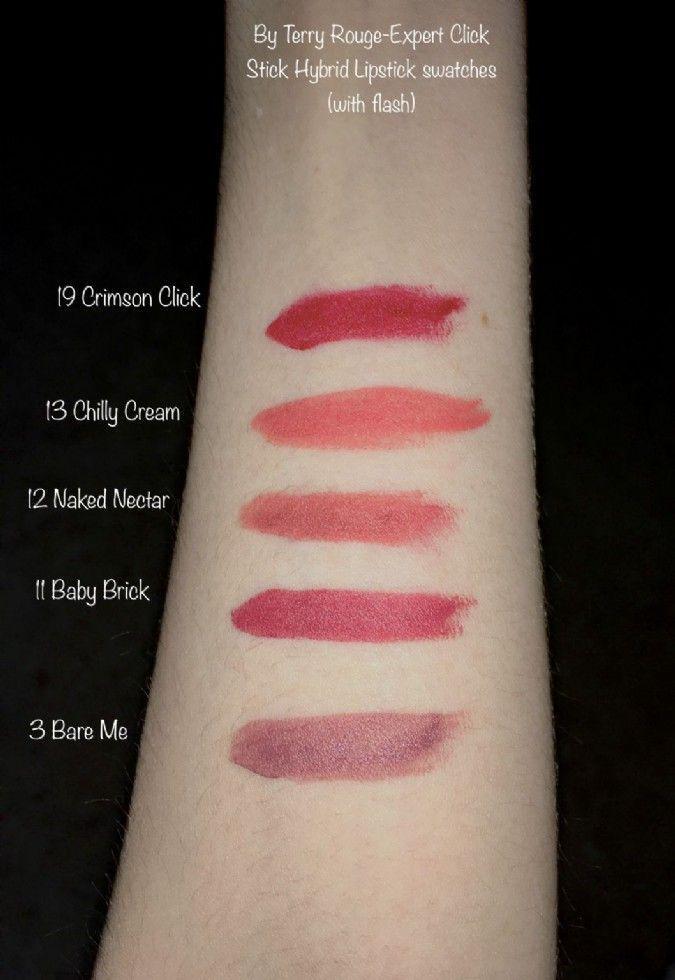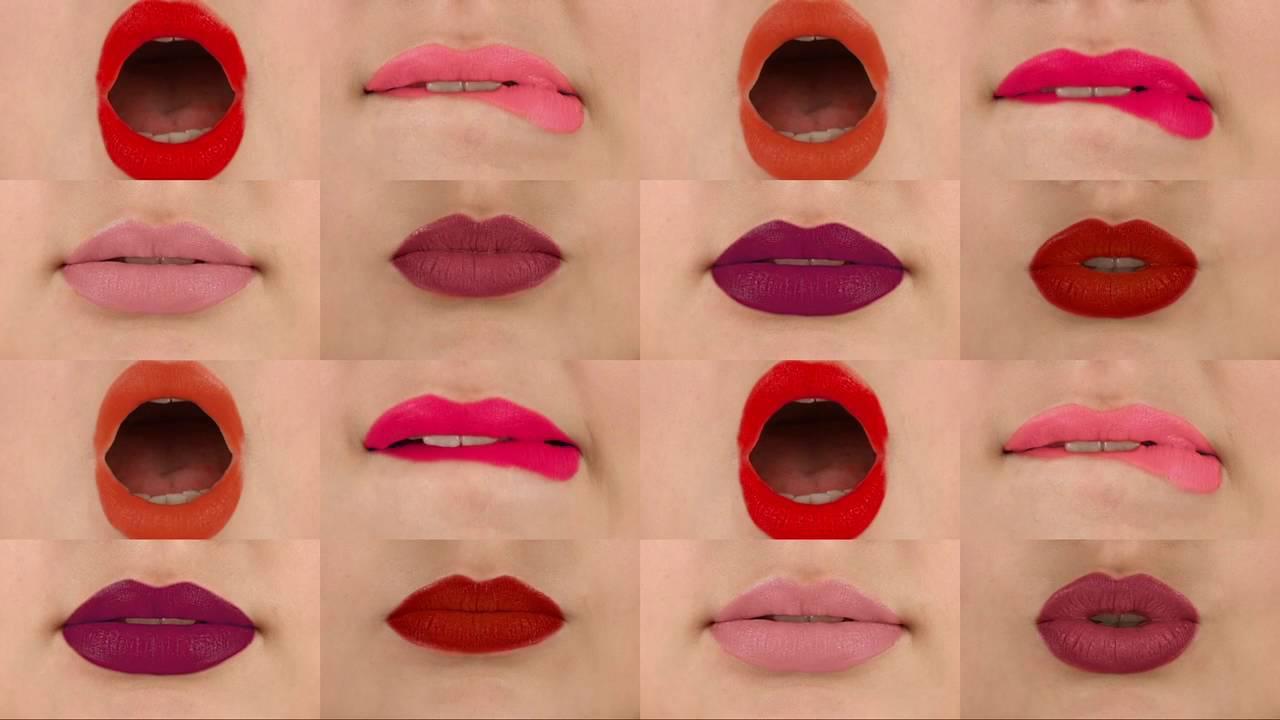The first image is the image on the left, the second image is the image on the right. For the images shown, is this caption "One of the images shows different shades of lipstick on human arm." true? Answer yes or no. Yes. The first image is the image on the left, the second image is the image on the right. Examine the images to the left and right. Is the description "An image shows smears of lipstick across at least one inner arm." accurate? Answer yes or no. Yes. 